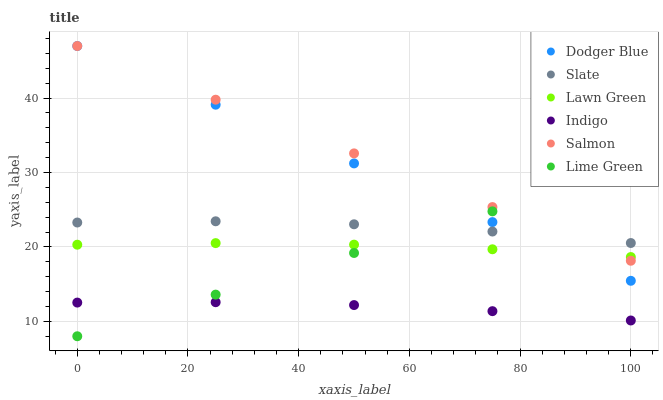Does Indigo have the minimum area under the curve?
Answer yes or no. Yes. Does Salmon have the maximum area under the curve?
Answer yes or no. Yes. Does Slate have the minimum area under the curve?
Answer yes or no. No. Does Slate have the maximum area under the curve?
Answer yes or no. No. Is Dodger Blue the smoothest?
Answer yes or no. Yes. Is Slate the roughest?
Answer yes or no. Yes. Is Indigo the smoothest?
Answer yes or no. No. Is Indigo the roughest?
Answer yes or no. No. Does Lime Green have the lowest value?
Answer yes or no. Yes. Does Indigo have the lowest value?
Answer yes or no. No. Does Dodger Blue have the highest value?
Answer yes or no. Yes. Does Slate have the highest value?
Answer yes or no. No. Is Indigo less than Dodger Blue?
Answer yes or no. Yes. Is Lawn Green greater than Indigo?
Answer yes or no. Yes. Does Lime Green intersect Slate?
Answer yes or no. Yes. Is Lime Green less than Slate?
Answer yes or no. No. Is Lime Green greater than Slate?
Answer yes or no. No. Does Indigo intersect Dodger Blue?
Answer yes or no. No. 